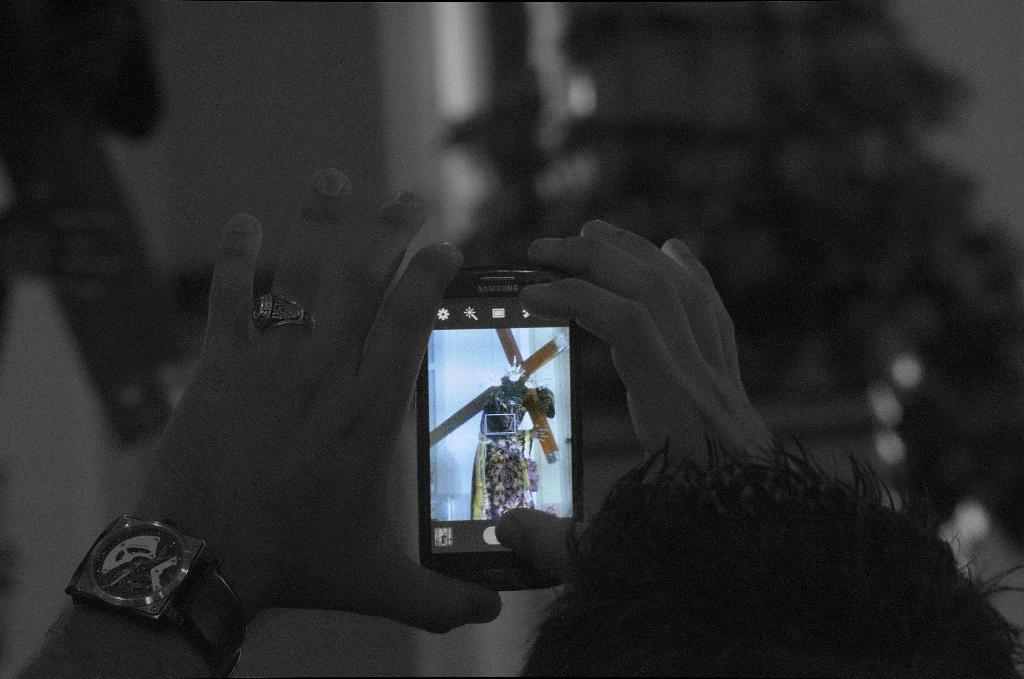What is present in the image? There is a person in the image. What is the person holding in their hands? The person is holding a mobile phone in their hands. What type of substance is the person using to express their opinion in the image? There is no substance or expression of opinion present in the image; it only shows a person holding a mobile phone. 